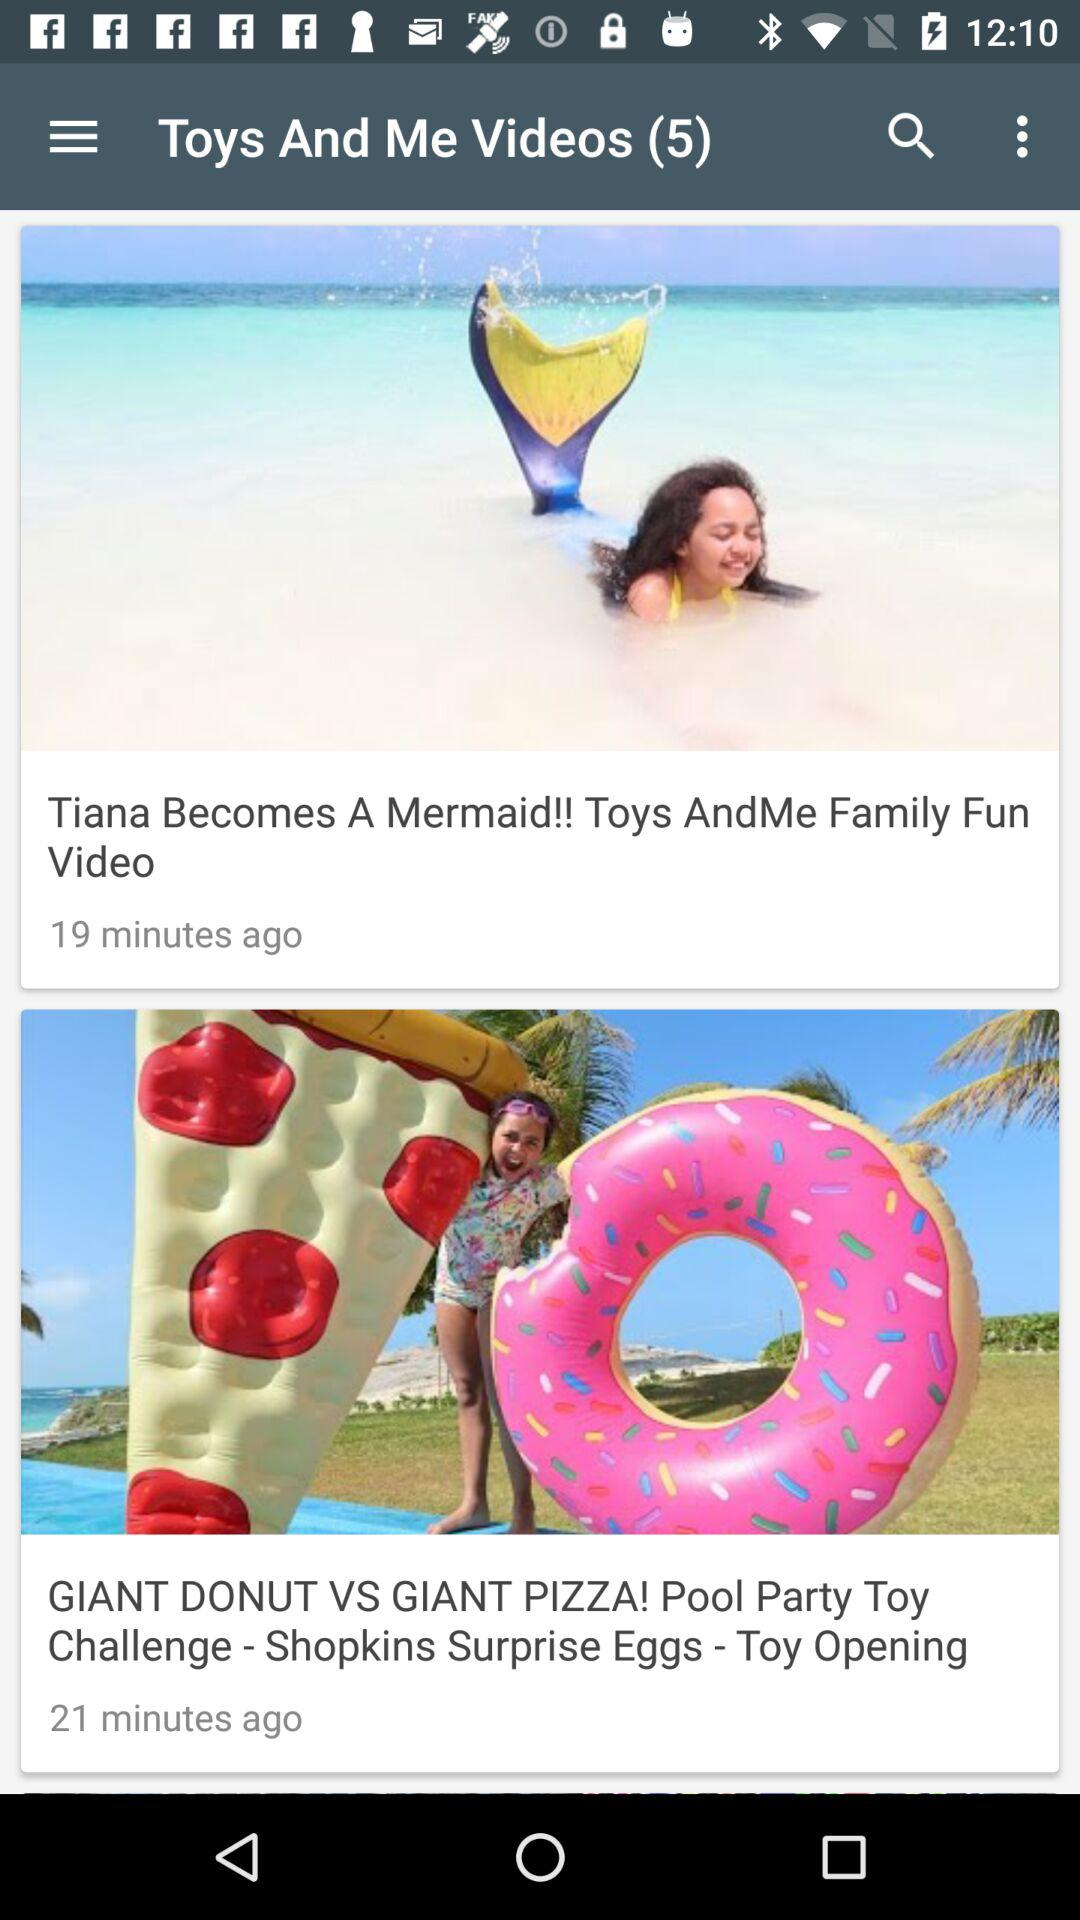How many new notifications have there been in "Toys And Me Videos"? There have been 5 new notifications. 